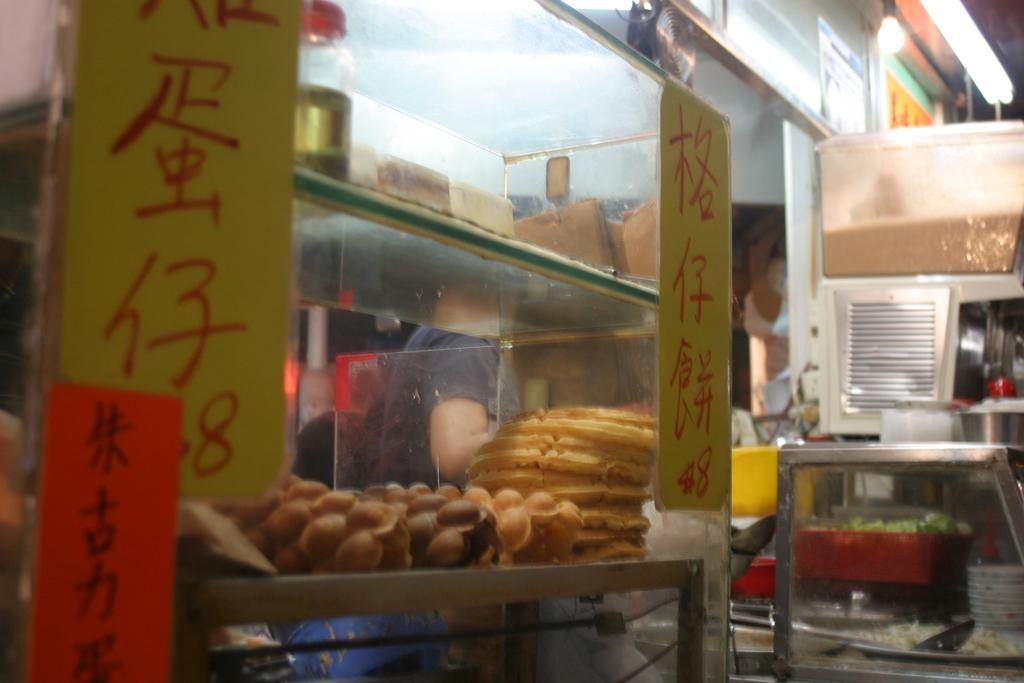What type of storage units are present in the image? There are glass cupboards in the image. What can be seen on the walls in the image? There are boards in the image, and something is written on them. Who is present in the image? There is a person in the image. What is visible in the image that might be used for eating or cooking? There is food in the image. What can be seen in the image that provides illumination? There are lights in the image. What else is present in the image besides the mentioned items? There are objects in the image. What type of plants can be seen growing on the sail in the image? There is no sail or plants present in the image. What trick is the person performing in the image? There is no trick being performed in the image; the person is simply present. 